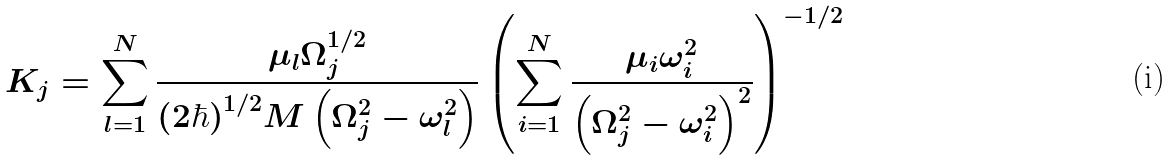Convert formula to latex. <formula><loc_0><loc_0><loc_500><loc_500>K _ { j } = \sum _ { l = 1 } ^ { N } \frac { \mu _ { l } \Omega _ { j } ^ { 1 / 2 } } { ( 2 \hbar { ) } ^ { 1 / 2 } M \left ( \Omega ^ { 2 } _ { j } - \omega ^ { 2 } _ { l } \right ) } \left ( \sum _ { i = 1 } ^ { N } \frac { \mu _ { i } \omega ^ { 2 } _ { i } } { \left ( \Omega ^ { 2 } _ { j } - \omega ^ { 2 } _ { i } \right ) ^ { 2 } } \right ) ^ { - 1 / 2 }</formula> 